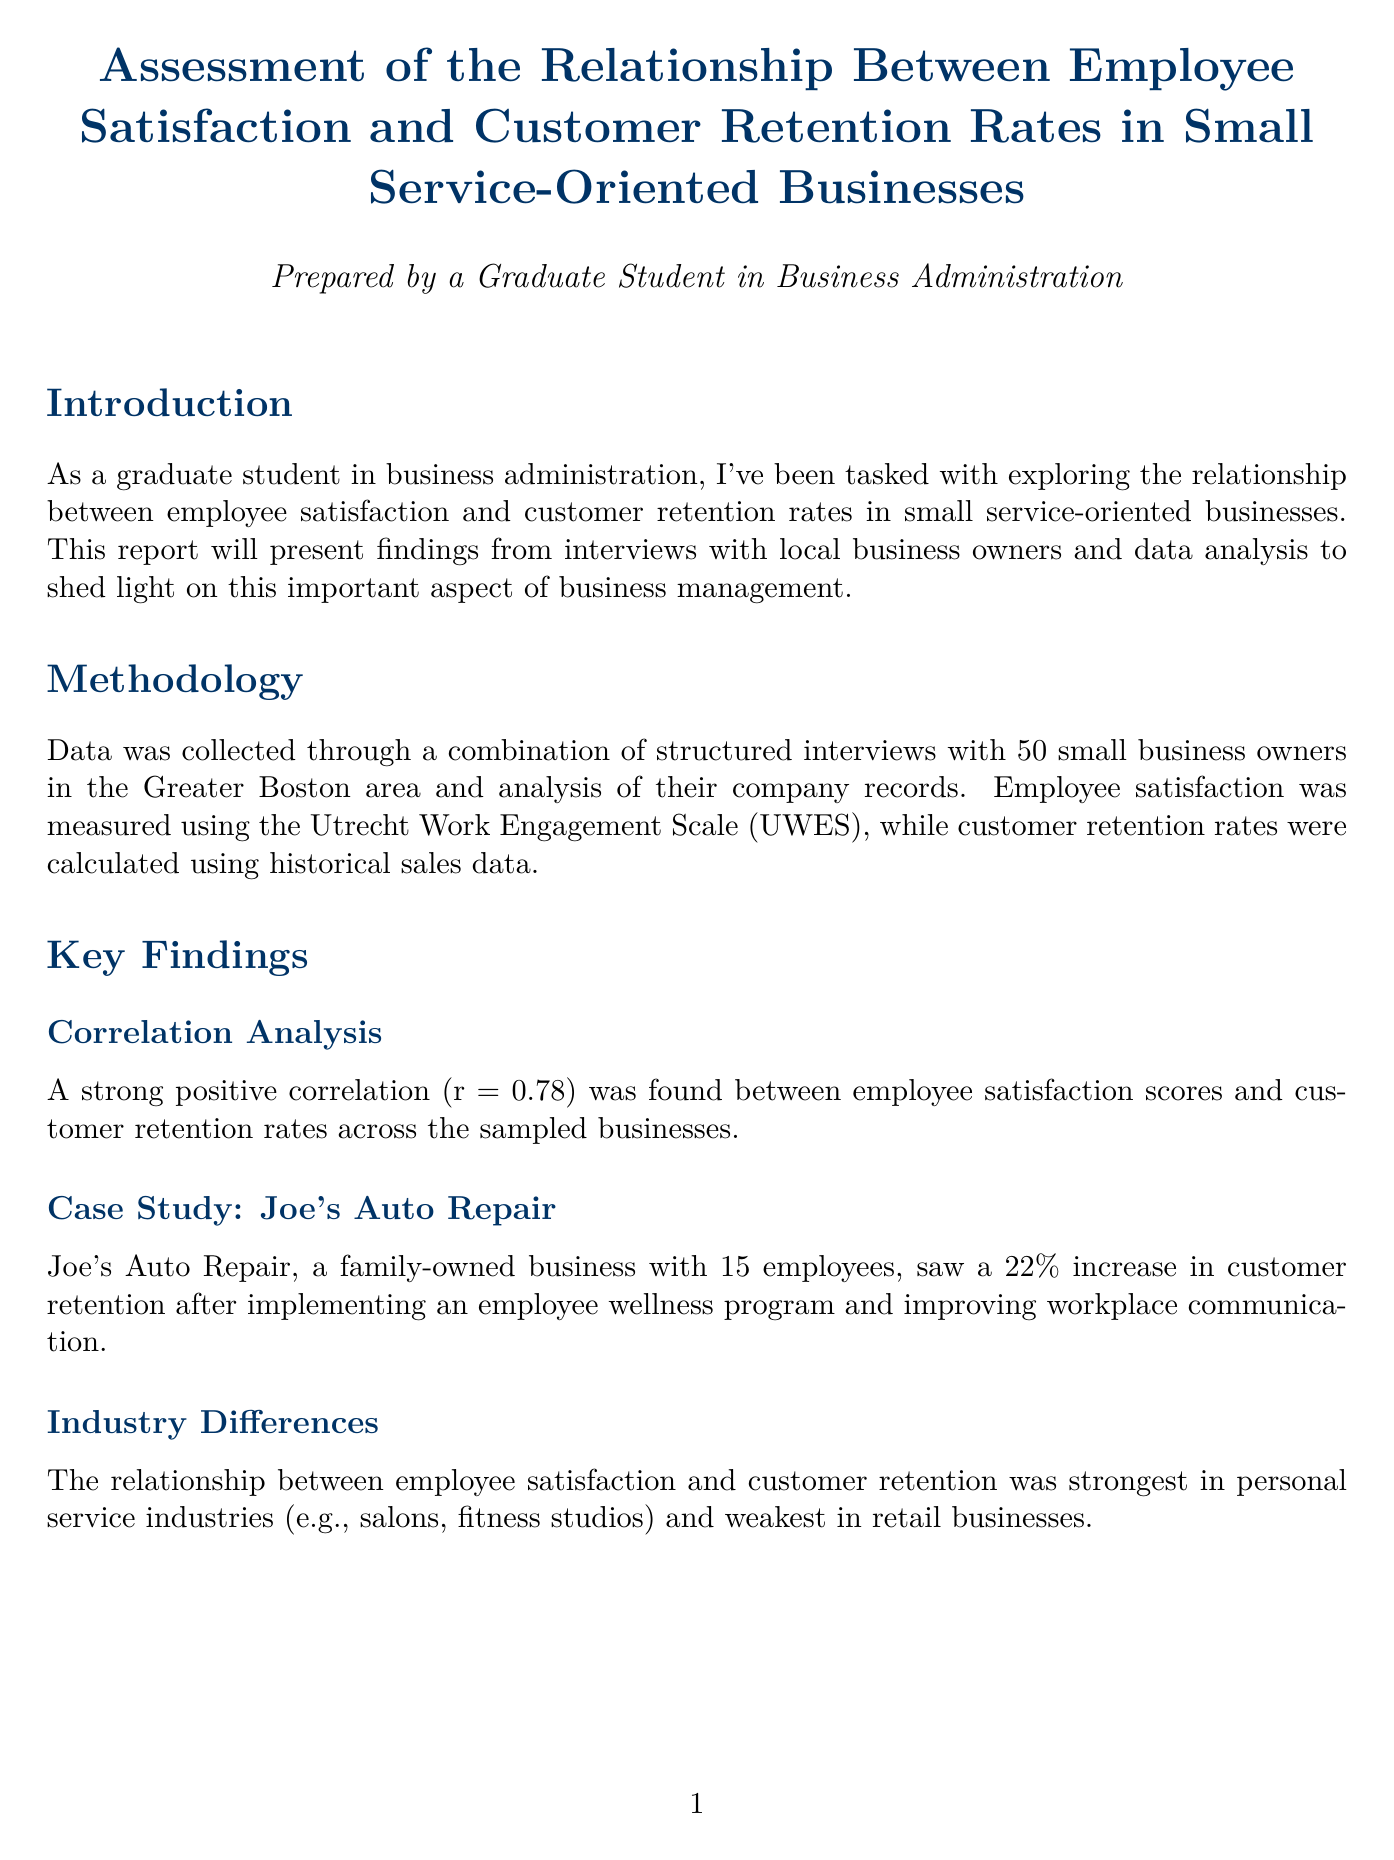What was the correlation coefficient found between employee satisfaction and customer retention? The document states that a strong positive correlation of r = 0.78 was found between employee satisfaction scores and customer retention rates.
Answer: r = 0.78 Who is the expert that commented on the findings of the study? The expert who provided insights is Dr. Sarah Chen, Professor of Organizational Behavior at Harvard Business School.
Answer: Dr. Sarah Chen What percentage increase in customer retention did Joe's Auto Repair experience? The report mentions that Joe's Auto Repair saw a 22% increase in customer retention after implementing their program.
Answer: 22% What is one recommendation for small business owners regarding employee satisfaction? The document includes several recommendations, such as implementing regular employee satisfaction surveys using validated tools like the UWES.
Answer: Implement regular employee satisfaction surveys What industry showed the strongest relationship between employee satisfaction and customer retention? The report indicates that the personal service industries, such as salons and fitness studios, had the strongest relationship.
Answer: Personal service industries What method was used to measure employee satisfaction? Employee satisfaction was measured using the Utrecht Work Engagement Scale (UWES).
Answer: Utrecht Work Engagement Scale (UWES) What limitation is mentioned regarding the study's findings? A limitation noted is the small sample size and potential regional bias, focusing on the Greater Boston area.
Answer: Small sample size and potential regional bias What type of businesses were interviewed for the study? The study involved structured interviews with 50 small business owners from small service-oriented businesses.
Answer: Small service-oriented businesses 